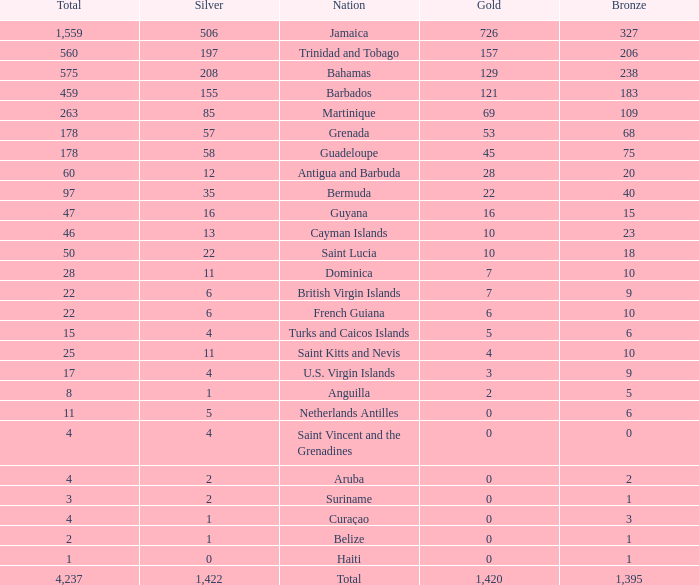What's the sum of Gold with a Bronze that's larger than 15, Silver that's smaller than 197, the Nation of Saint Lucia, and has a Total that is larger than 50? None. 